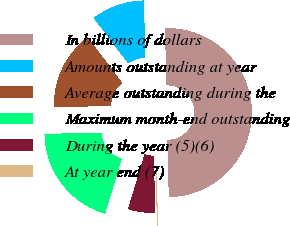<chart> <loc_0><loc_0><loc_500><loc_500><pie_chart><fcel>In billions of dollars<fcel>Amounts outstanding at year<fcel>Average outstanding during the<fcel>Maximum month-end outstanding<fcel>During the year (5)(6)<fcel>At year end (7)<nl><fcel>49.96%<fcel>10.01%<fcel>15.0%<fcel>20.0%<fcel>5.01%<fcel>0.02%<nl></chart> 